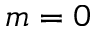<formula> <loc_0><loc_0><loc_500><loc_500>m = 0</formula> 